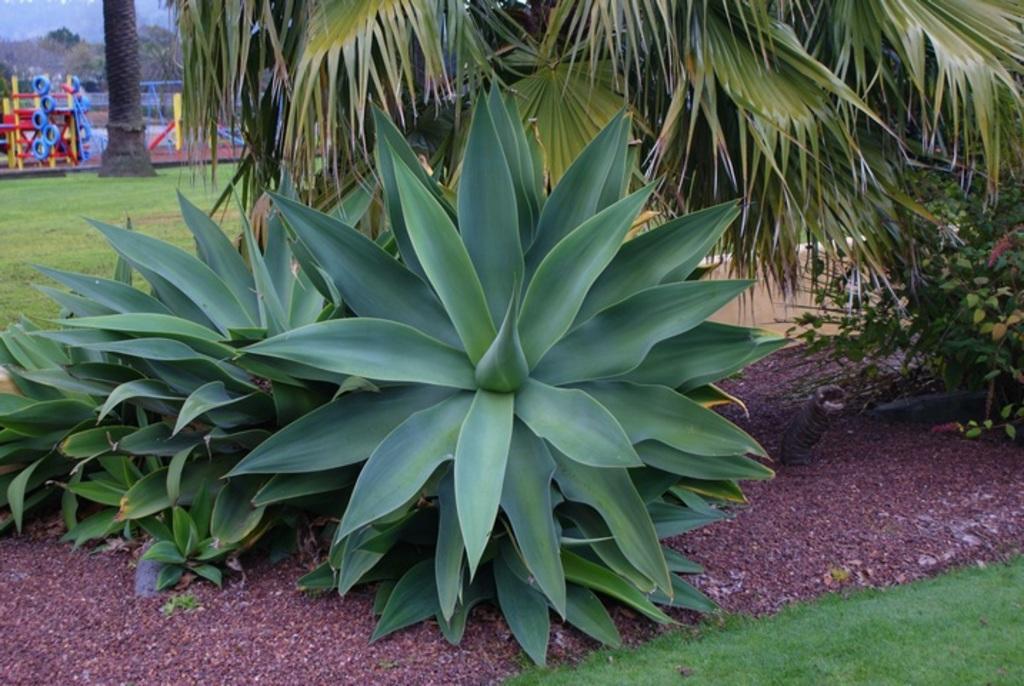Please provide a concise description of this image. In this image there is the sky towards the top of the image, there is a tree trunk towards the top of the image, there is an object towards the left of the image, there is grass towards the left of the image, there is grass towards the bottom of the image, there are plants, there is soil, there is an object in the soil. 